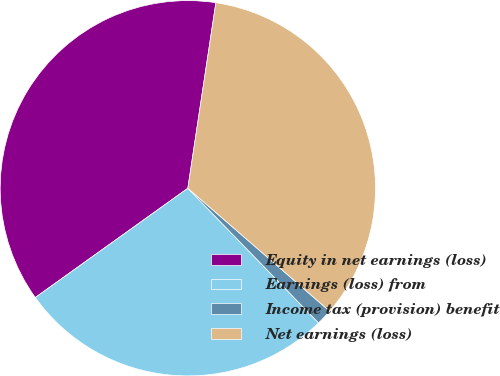<chart> <loc_0><loc_0><loc_500><loc_500><pie_chart><fcel>Equity in net earnings (loss)<fcel>Earnings (loss) from<fcel>Income tax (provision) benefit<fcel>Net earnings (loss)<nl><fcel>37.28%<fcel>27.37%<fcel>1.37%<fcel>33.98%<nl></chart> 